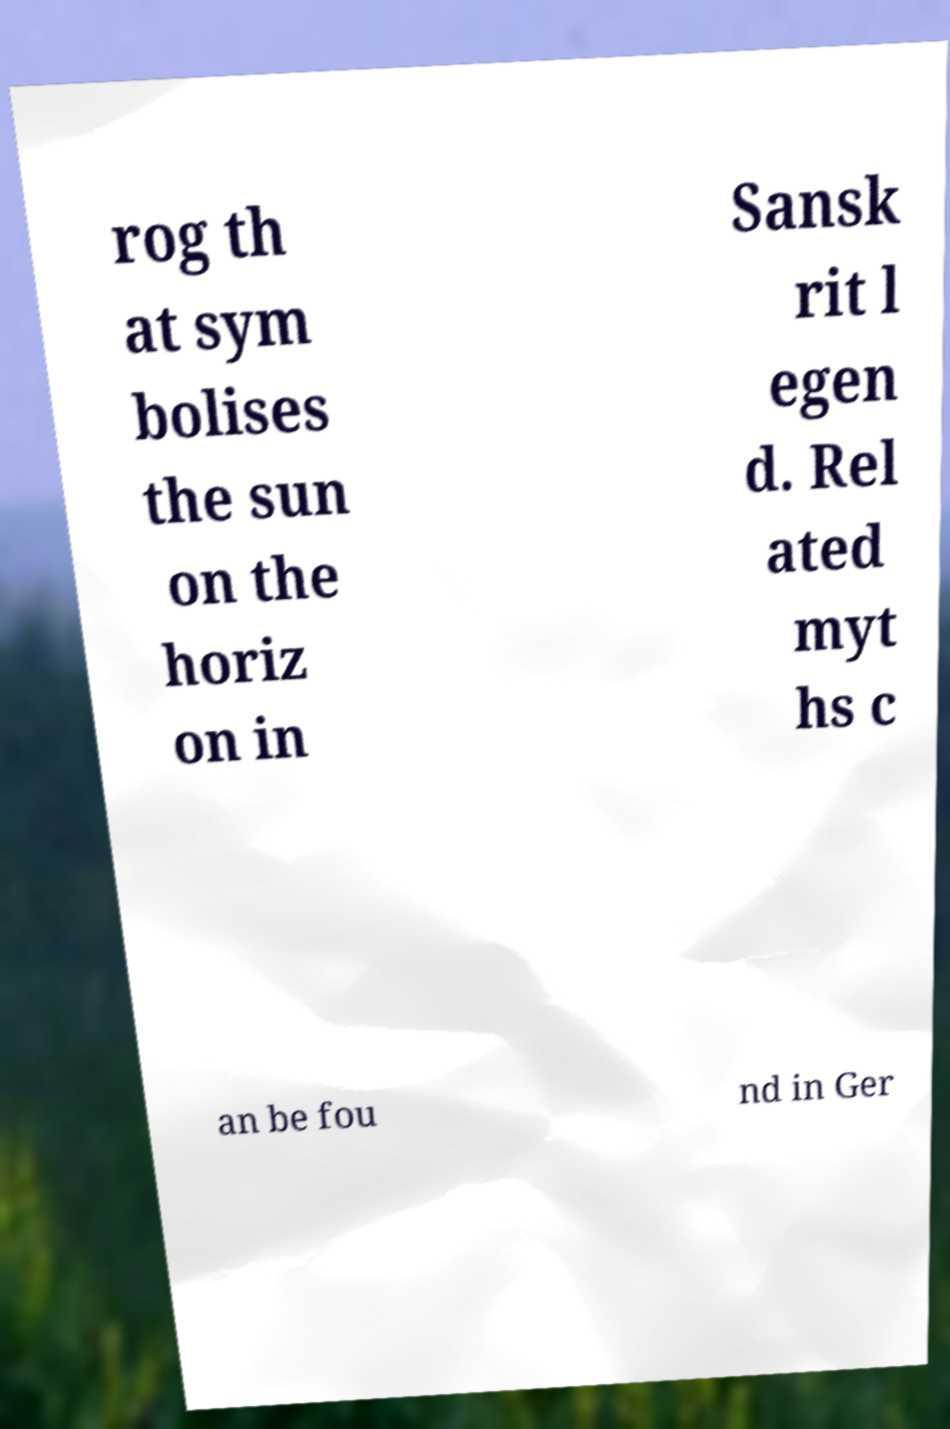Can you accurately transcribe the text from the provided image for me? rog th at sym bolises the sun on the horiz on in Sansk rit l egen d. Rel ated myt hs c an be fou nd in Ger 